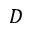<formula> <loc_0><loc_0><loc_500><loc_500>D</formula> 